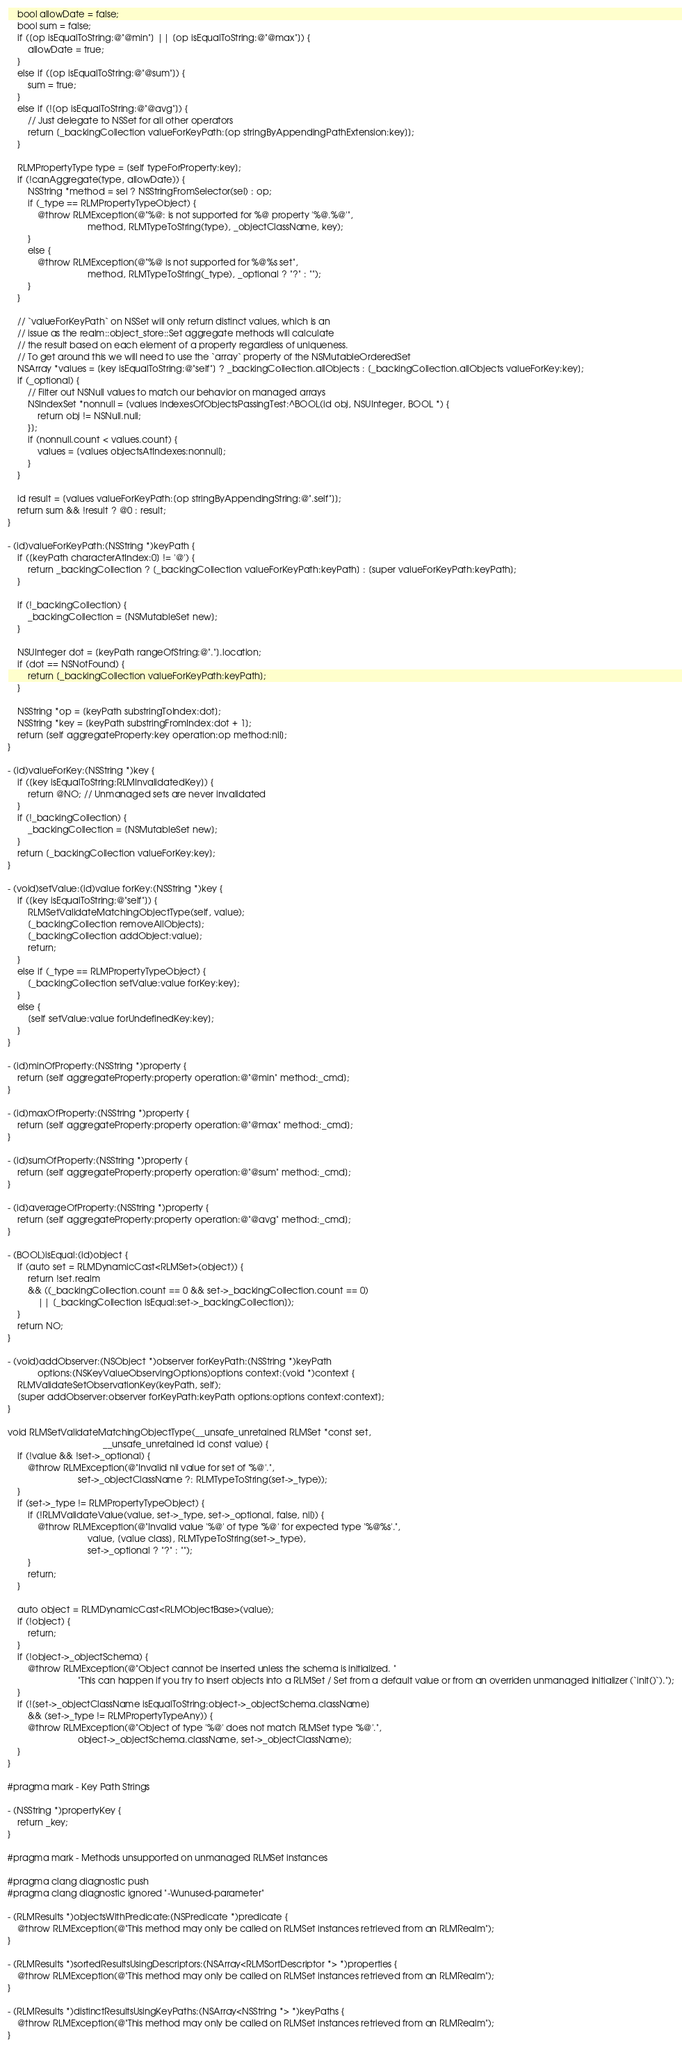<code> <loc_0><loc_0><loc_500><loc_500><_ObjectiveC_>    bool allowDate = false;
    bool sum = false;
    if ([op isEqualToString:@"@min"] || [op isEqualToString:@"@max"]) {
        allowDate = true;
    }
    else if ([op isEqualToString:@"@sum"]) {
        sum = true;
    }
    else if (![op isEqualToString:@"@avg"]) {
        // Just delegate to NSSet for all other operators
        return [_backingCollection valueForKeyPath:[op stringByAppendingPathExtension:key]];
    }

    RLMPropertyType type = [self typeForProperty:key];
    if (!canAggregate(type, allowDate)) {
        NSString *method = sel ? NSStringFromSelector(sel) : op;
        if (_type == RLMPropertyTypeObject) {
            @throw RLMException(@"%@: is not supported for %@ property '%@.%@'",
                                method, RLMTypeToString(type), _objectClassName, key);
        }
        else {
            @throw RLMException(@"%@ is not supported for %@%s set",
                                method, RLMTypeToString(_type), _optional ? "?" : "");
        }
    }

    // `valueForKeyPath` on NSSet will only return distinct values, which is an
    // issue as the realm::object_store::Set aggregate methods will calculate
    // the result based on each element of a property regardless of uniqueness.
    // To get around this we will need to use the `array` property of the NSMutableOrderedSet
    NSArray *values = [key isEqualToString:@"self"] ? _backingCollection.allObjects : [_backingCollection.allObjects valueForKey:key];
    if (_optional) {
        // Filter out NSNull values to match our behavior on managed arrays
        NSIndexSet *nonnull = [values indexesOfObjectsPassingTest:^BOOL(id obj, NSUInteger, BOOL *) {
            return obj != NSNull.null;
        }];
        if (nonnull.count < values.count) {
            values = [values objectsAtIndexes:nonnull];
        }
    }

    id result = [values valueForKeyPath:[op stringByAppendingString:@".self"]];
    return sum && !result ? @0 : result;
}

- (id)valueForKeyPath:(NSString *)keyPath {
    if ([keyPath characterAtIndex:0] != '@') {
        return _backingCollection ? [_backingCollection valueForKeyPath:keyPath] : [super valueForKeyPath:keyPath];
    }

    if (!_backingCollection) {
        _backingCollection = [NSMutableSet new];
    }

    NSUInteger dot = [keyPath rangeOfString:@"."].location;
    if (dot == NSNotFound) {
        return [_backingCollection valueForKeyPath:keyPath];
    }

    NSString *op = [keyPath substringToIndex:dot];
    NSString *key = [keyPath substringFromIndex:dot + 1];
    return [self aggregateProperty:key operation:op method:nil];
}

- (id)valueForKey:(NSString *)key {
    if ([key isEqualToString:RLMInvalidatedKey]) {
        return @NO; // Unmanaged sets are never invalidated
    }
    if (!_backingCollection) {
        _backingCollection = [NSMutableSet new];
    }
    return [_backingCollection valueForKey:key];
}

- (void)setValue:(id)value forKey:(NSString *)key {
    if ([key isEqualToString:@"self"]) {
        RLMSetValidateMatchingObjectType(self, value);
        [_backingCollection removeAllObjects];
        [_backingCollection addObject:value];
        return;
    }
    else if (_type == RLMPropertyTypeObject) {
        [_backingCollection setValue:value forKey:key];
    }
    else {
        [self setValue:value forUndefinedKey:key];
    }
}

- (id)minOfProperty:(NSString *)property {
    return [self aggregateProperty:property operation:@"@min" method:_cmd];
}

- (id)maxOfProperty:(NSString *)property {
    return [self aggregateProperty:property operation:@"@max" method:_cmd];
}

- (id)sumOfProperty:(NSString *)property {
    return [self aggregateProperty:property operation:@"@sum" method:_cmd];
}

- (id)averageOfProperty:(NSString *)property {
    return [self aggregateProperty:property operation:@"@avg" method:_cmd];
}

- (BOOL)isEqual:(id)object {
    if (auto set = RLMDynamicCast<RLMSet>(object)) {
        return !set.realm
        && ((_backingCollection.count == 0 && set->_backingCollection.count == 0)
            || [_backingCollection isEqual:set->_backingCollection]);
    }
    return NO;
}

- (void)addObserver:(NSObject *)observer forKeyPath:(NSString *)keyPath
            options:(NSKeyValueObservingOptions)options context:(void *)context {
    RLMValidateSetObservationKey(keyPath, self);
    [super addObserver:observer forKeyPath:keyPath options:options context:context];
}

void RLMSetValidateMatchingObjectType(__unsafe_unretained RLMSet *const set,
                                      __unsafe_unretained id const value) {
    if (!value && !set->_optional) {
        @throw RLMException(@"Invalid nil value for set of '%@'.",
                            set->_objectClassName ?: RLMTypeToString(set->_type));
    }
    if (set->_type != RLMPropertyTypeObject) {
        if (!RLMValidateValue(value, set->_type, set->_optional, false, nil)) {
            @throw RLMException(@"Invalid value '%@' of type '%@' for expected type '%@%s'.",
                                value, [value class], RLMTypeToString(set->_type),
                                set->_optional ? "?" : "");
        }
        return;
    }

    auto object = RLMDynamicCast<RLMObjectBase>(value);
    if (!object) {
        return;
    }
    if (!object->_objectSchema) {
        @throw RLMException(@"Object cannot be inserted unless the schema is initialized. "
                            "This can happen if you try to insert objects into a RLMSet / Set from a default value or from an overriden unmanaged initializer (`init()`).");
    }
    if (![set->_objectClassName isEqualToString:object->_objectSchema.className]
        && (set->_type != RLMPropertyTypeAny)) {
        @throw RLMException(@"Object of type '%@' does not match RLMSet type '%@'.",
                            object->_objectSchema.className, set->_objectClassName);
    }
}

#pragma mark - Key Path Strings

- (NSString *)propertyKey {
    return _key;
}

#pragma mark - Methods unsupported on unmanaged RLMSet instances

#pragma clang diagnostic push
#pragma clang diagnostic ignored "-Wunused-parameter"

- (RLMResults *)objectsWithPredicate:(NSPredicate *)predicate {
    @throw RLMException(@"This method may only be called on RLMSet instances retrieved from an RLMRealm");
}

- (RLMResults *)sortedResultsUsingDescriptors:(NSArray<RLMSortDescriptor *> *)properties {
    @throw RLMException(@"This method may only be called on RLMSet instances retrieved from an RLMRealm");
}

- (RLMResults *)distinctResultsUsingKeyPaths:(NSArray<NSString *> *)keyPaths {
    @throw RLMException(@"This method may only be called on RLMSet instances retrieved from an RLMRealm");
}
</code> 